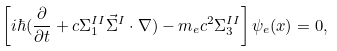Convert formula to latex. <formula><loc_0><loc_0><loc_500><loc_500>\left [ i \hbar { ( } \frac { \partial } { \partial t } + c \Sigma ^ { I I } _ { 1 } \vec { \Sigma } ^ { I } \cdot \nabla ) - m _ { e } c ^ { 2 } \Sigma _ { 3 } ^ { I I } \right ] \psi _ { e } ( x ) = 0 ,</formula> 